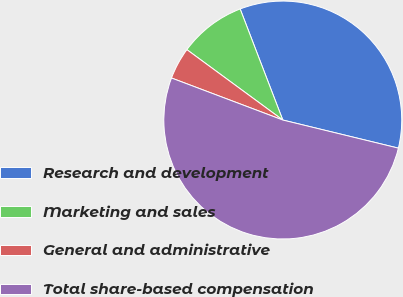Convert chart. <chart><loc_0><loc_0><loc_500><loc_500><pie_chart><fcel>Research and development<fcel>Marketing and sales<fcel>General and administrative<fcel>Total share-based compensation<nl><fcel>34.63%<fcel>9.09%<fcel>4.33%<fcel>51.95%<nl></chart> 